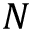Convert formula to latex. <formula><loc_0><loc_0><loc_500><loc_500>N</formula> 